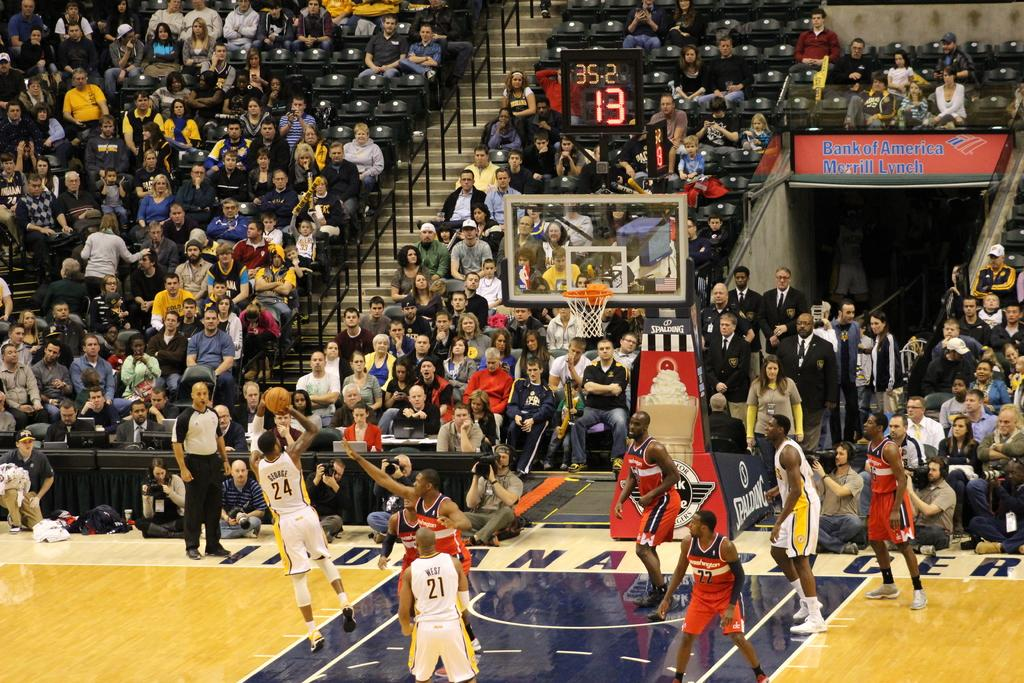<image>
Summarize the visual content of the image. Player number 24 is about to take a shot as a player from the other team tries to stop him. 